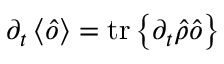<formula> <loc_0><loc_0><loc_500><loc_500>\partial _ { t } \left \langle \hat { o } \right \rangle = t r \left \{ \partial _ { t } \hat { \rho } \hat { o } \right \}</formula> 